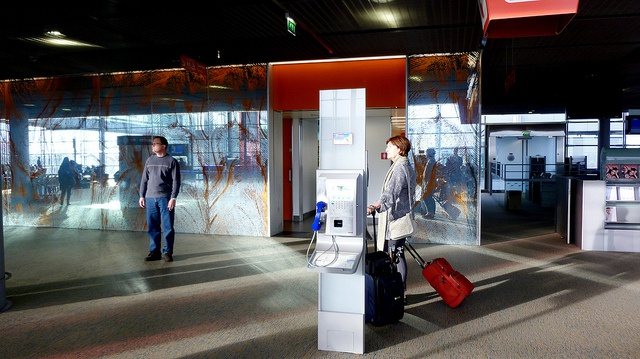Describe the objects in this image and their specific colors. I can see people in black, gray, and navy tones, suitcase in black, navy, gray, and darkgray tones, people in black, gray, lightgray, and darkgray tones, suitcase in black, maroon, and gray tones, and people in black, maroon, blue, navy, and gray tones in this image. 